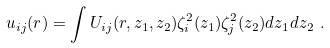Convert formula to latex. <formula><loc_0><loc_0><loc_500><loc_500>u _ { i j } ( r ) = \int U _ { i j } ( r , z _ { 1 } , z _ { 2 } ) \zeta _ { i } ^ { 2 } ( z _ { 1 } ) \zeta _ { j } ^ { 2 } ( z _ { 2 } ) d z _ { 1 } d z _ { 2 } \ .</formula> 